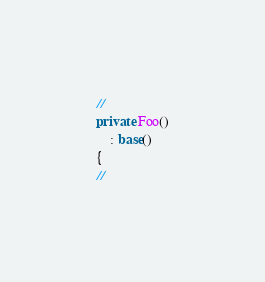<code> <loc_0><loc_0><loc_500><loc_500><_C#_>//
private Foo()
    : base()
{
//
</code> 